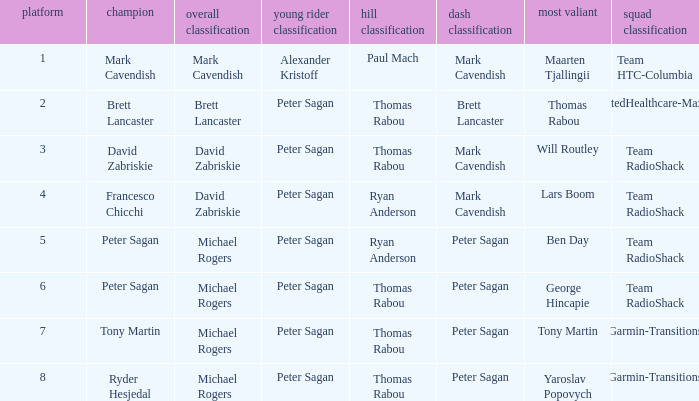When Yaroslav Popovych won most corageous, who won the mountains classification? Thomas Rabou. 